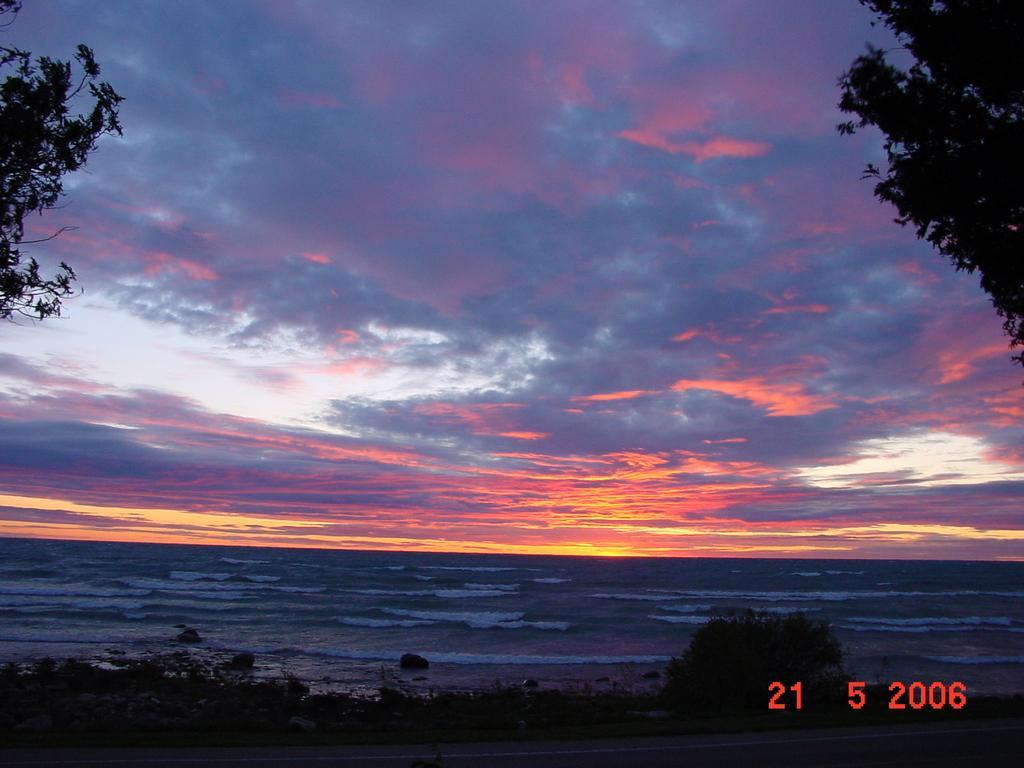Please provide a concise description of this image. In the center of the image we can see the sky,clouds,trees,water etc. In the bottom right side of the image,we can see some text. 